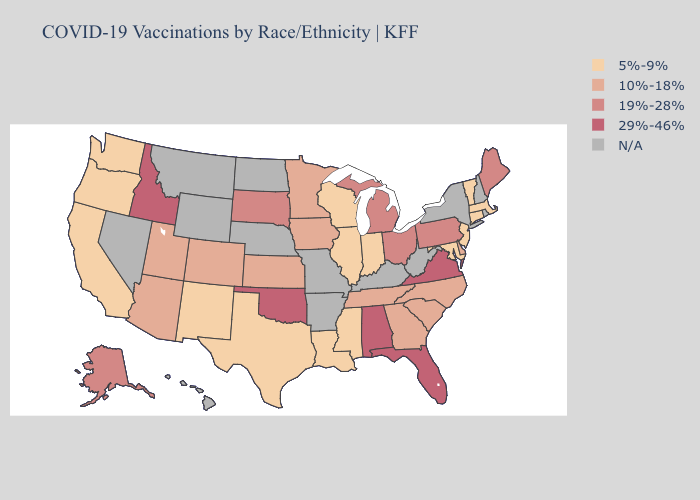Does the first symbol in the legend represent the smallest category?
Be succinct. Yes. What is the lowest value in states that border South Carolina?
Short answer required. 10%-18%. Name the states that have a value in the range N/A?
Write a very short answer. Arkansas, Hawaii, Kentucky, Missouri, Montana, Nebraska, Nevada, New Hampshire, New York, North Dakota, Rhode Island, West Virginia, Wyoming. Does Idaho have the highest value in the USA?
Keep it brief. Yes. What is the value of Michigan?
Short answer required. 19%-28%. Which states have the highest value in the USA?
Keep it brief. Alabama, Florida, Idaho, Oklahoma, Virginia. What is the value of Oklahoma?
Write a very short answer. 29%-46%. What is the lowest value in the MidWest?
Concise answer only. 5%-9%. What is the value of Arizona?
Short answer required. 10%-18%. What is the value of Kansas?
Write a very short answer. 10%-18%. What is the value of Kentucky?
Concise answer only. N/A. Name the states that have a value in the range 10%-18%?
Give a very brief answer. Arizona, Colorado, Delaware, Georgia, Iowa, Kansas, Minnesota, North Carolina, South Carolina, Tennessee, Utah. Does Pennsylvania have the lowest value in the USA?
Be succinct. No. Which states have the highest value in the USA?
Be succinct. Alabama, Florida, Idaho, Oklahoma, Virginia. 